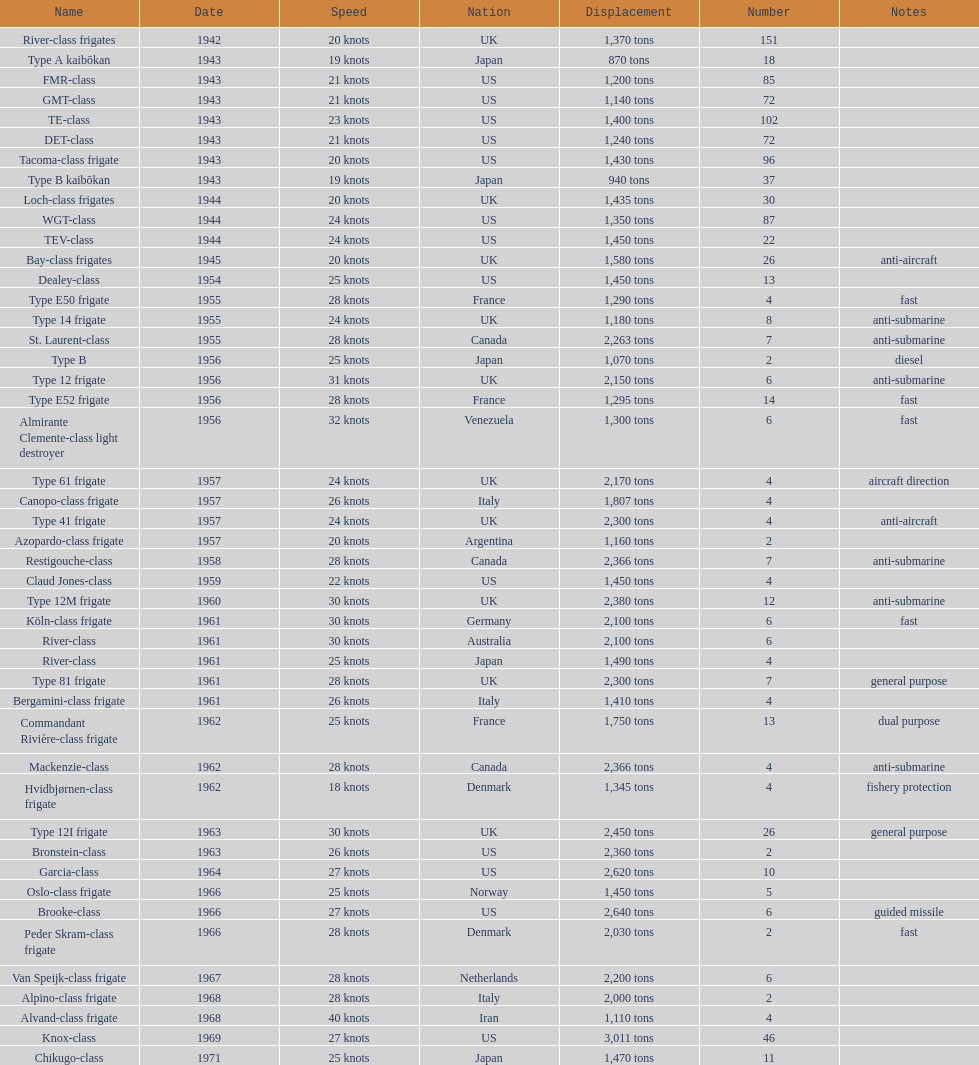Which name has the largest displacement? Knox-class. 